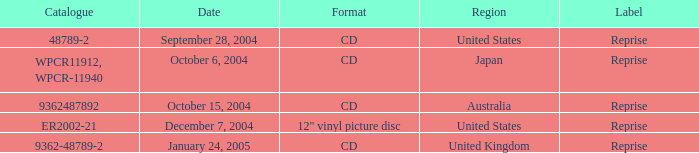Name the date that is a cd September 28, 2004, October 6, 2004, October 15, 2004, January 24, 2005. 